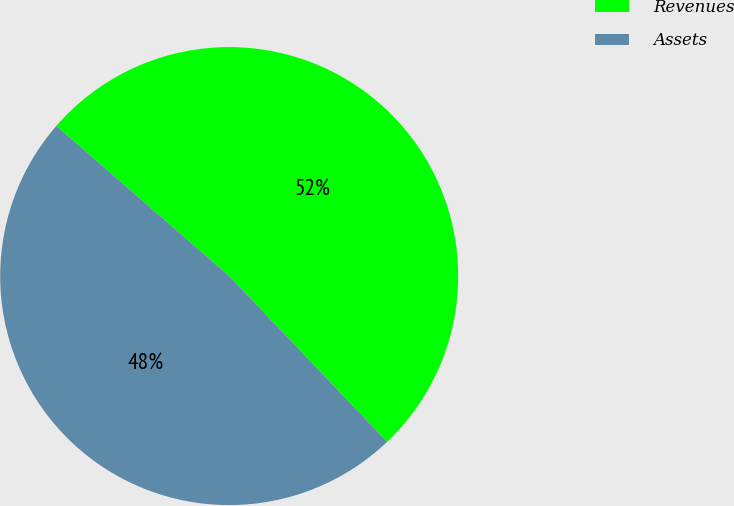Convert chart. <chart><loc_0><loc_0><loc_500><loc_500><pie_chart><fcel>Revenues<fcel>Assets<nl><fcel>51.5%<fcel>48.5%<nl></chart> 